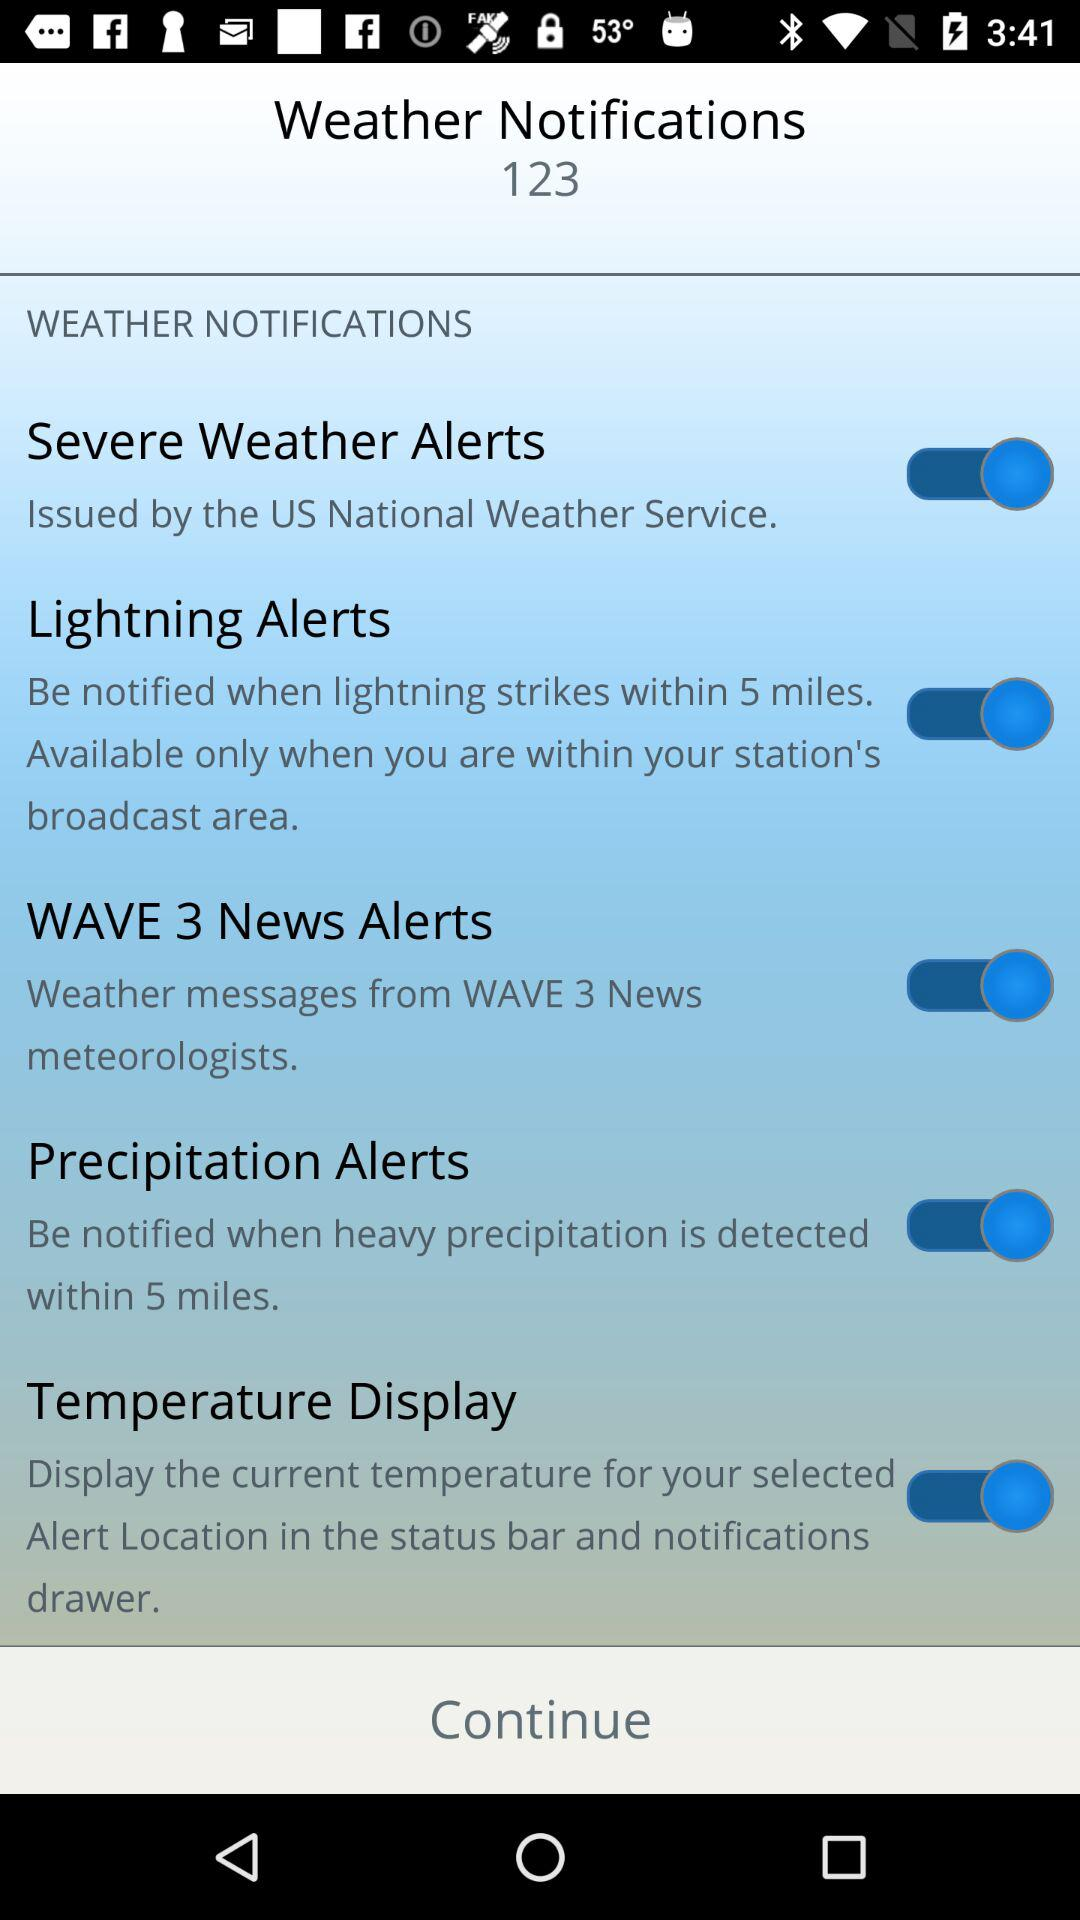Within how many miles do "Lightning Alerts" generate a notification? "Lightning Alerts" generate a notification within 5 miles. 